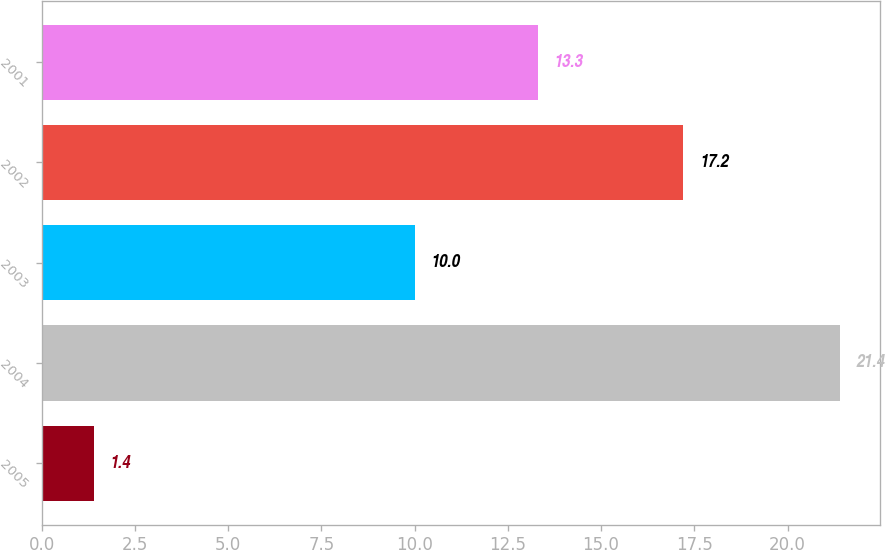<chart> <loc_0><loc_0><loc_500><loc_500><bar_chart><fcel>2005<fcel>2004<fcel>2003<fcel>2002<fcel>2001<nl><fcel>1.4<fcel>21.4<fcel>10<fcel>17.2<fcel>13.3<nl></chart> 